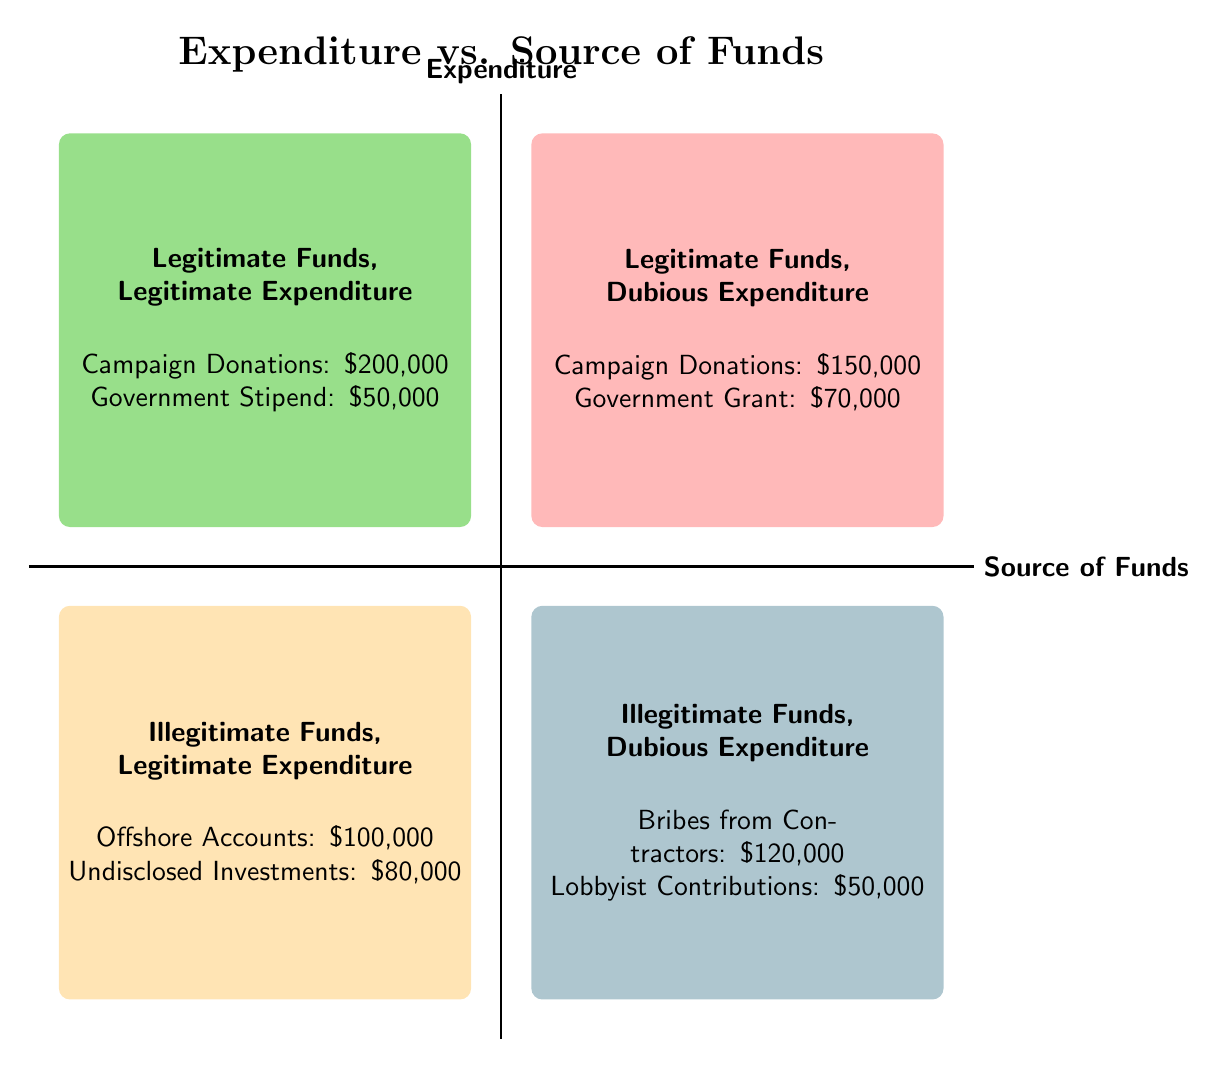What is the total amount of campaign donations in the legitimate funds quadrant? In the quadrant labeled "Legitimate Funds, Legitimate Expenditure," there are campaign donations totaling $200,000 in the first quadrant and $150,000 in the second quadrant. Adding these amounts gives $200,000 + $150,000 = $350,000.
Answer: $350,000 How much is spent on bribes from contractors? In the quadrant labeled "Illegitimate Funds, Dubious Expenditure," bribes from contractors have an amount of $120,000. This value is provided directly within the quadrant.
Answer: $120,000 Which quadrant contains offshore accounts? Offshore accounts are listed under the quadrant labeled "Illegitimate Funds, Legitimate Expenditure," as indicated by the element present in that quadrant.
Answer: Illegitimate Funds, Legitimate Expenditure What is the total expenditure from legitimate funds? In the quadrants for legitimate funds, "Legitimate Funds, Legitimate Expenditure" shows $250,000 (as $200,000 + $50,000) and "Legitimate Funds, Dubious Expenditure" shows $220,000 (as $150,000 + $70,000). Adding these two expenditures gives $250,000 + $220,000 = $470,000.
Answer: $470,000 Which source of funds is linked to dubious expenditure? The "Legitimate Funds, Dubious Expenditure" quadrant contains "Campaign Donations" and "Government Grant." Therefore, both these sources are linked to dubious expenditure.
Answer: Campaign Donations, Government Grant How much is attributed to offshore accounts and undisclosed investments together? In the quadrant labeled "Illegitimate Funds, Legitimate Expenditure," offshore accounts amount to $100,000 and undisclosed investments amount to $80,000. Adding these values results in $100,000 + $80,000 = $180,000.
Answer: $180,000 Which quadrant has the least amount of total expenditure? Upon calculating the total expenditure for each quadrant, "Illegitimate Funds, Dubious Expenditure" has the least with a total of $170,000 (as $120,000 + $50,000). Comparing this with the other quadrants shows that this total is lower.
Answer: Illegitimate Funds, Dubious Expenditure What is the total for government stipend and government grant? The government stipend appears in "Legitimate Funds, Legitimate Expenditure" with an amount of $50,000, while the government grant is located in "Legitimate Funds, Dubious Expenditure," with an amount of $70,000. Adding these gives $50,000 + $70,000 = $120,000.
Answer: $120,000 Which quadrant reports the highest total amount of expenditure? The sums for quadrants are $250,000, $220,000, $180,000, and $170,000. The highest total expenditure is found in "Legitimate Funds, Legitimate Expenditure," totaling $250,000.
Answer: Legitimate Funds, Legitimate Expenditure 